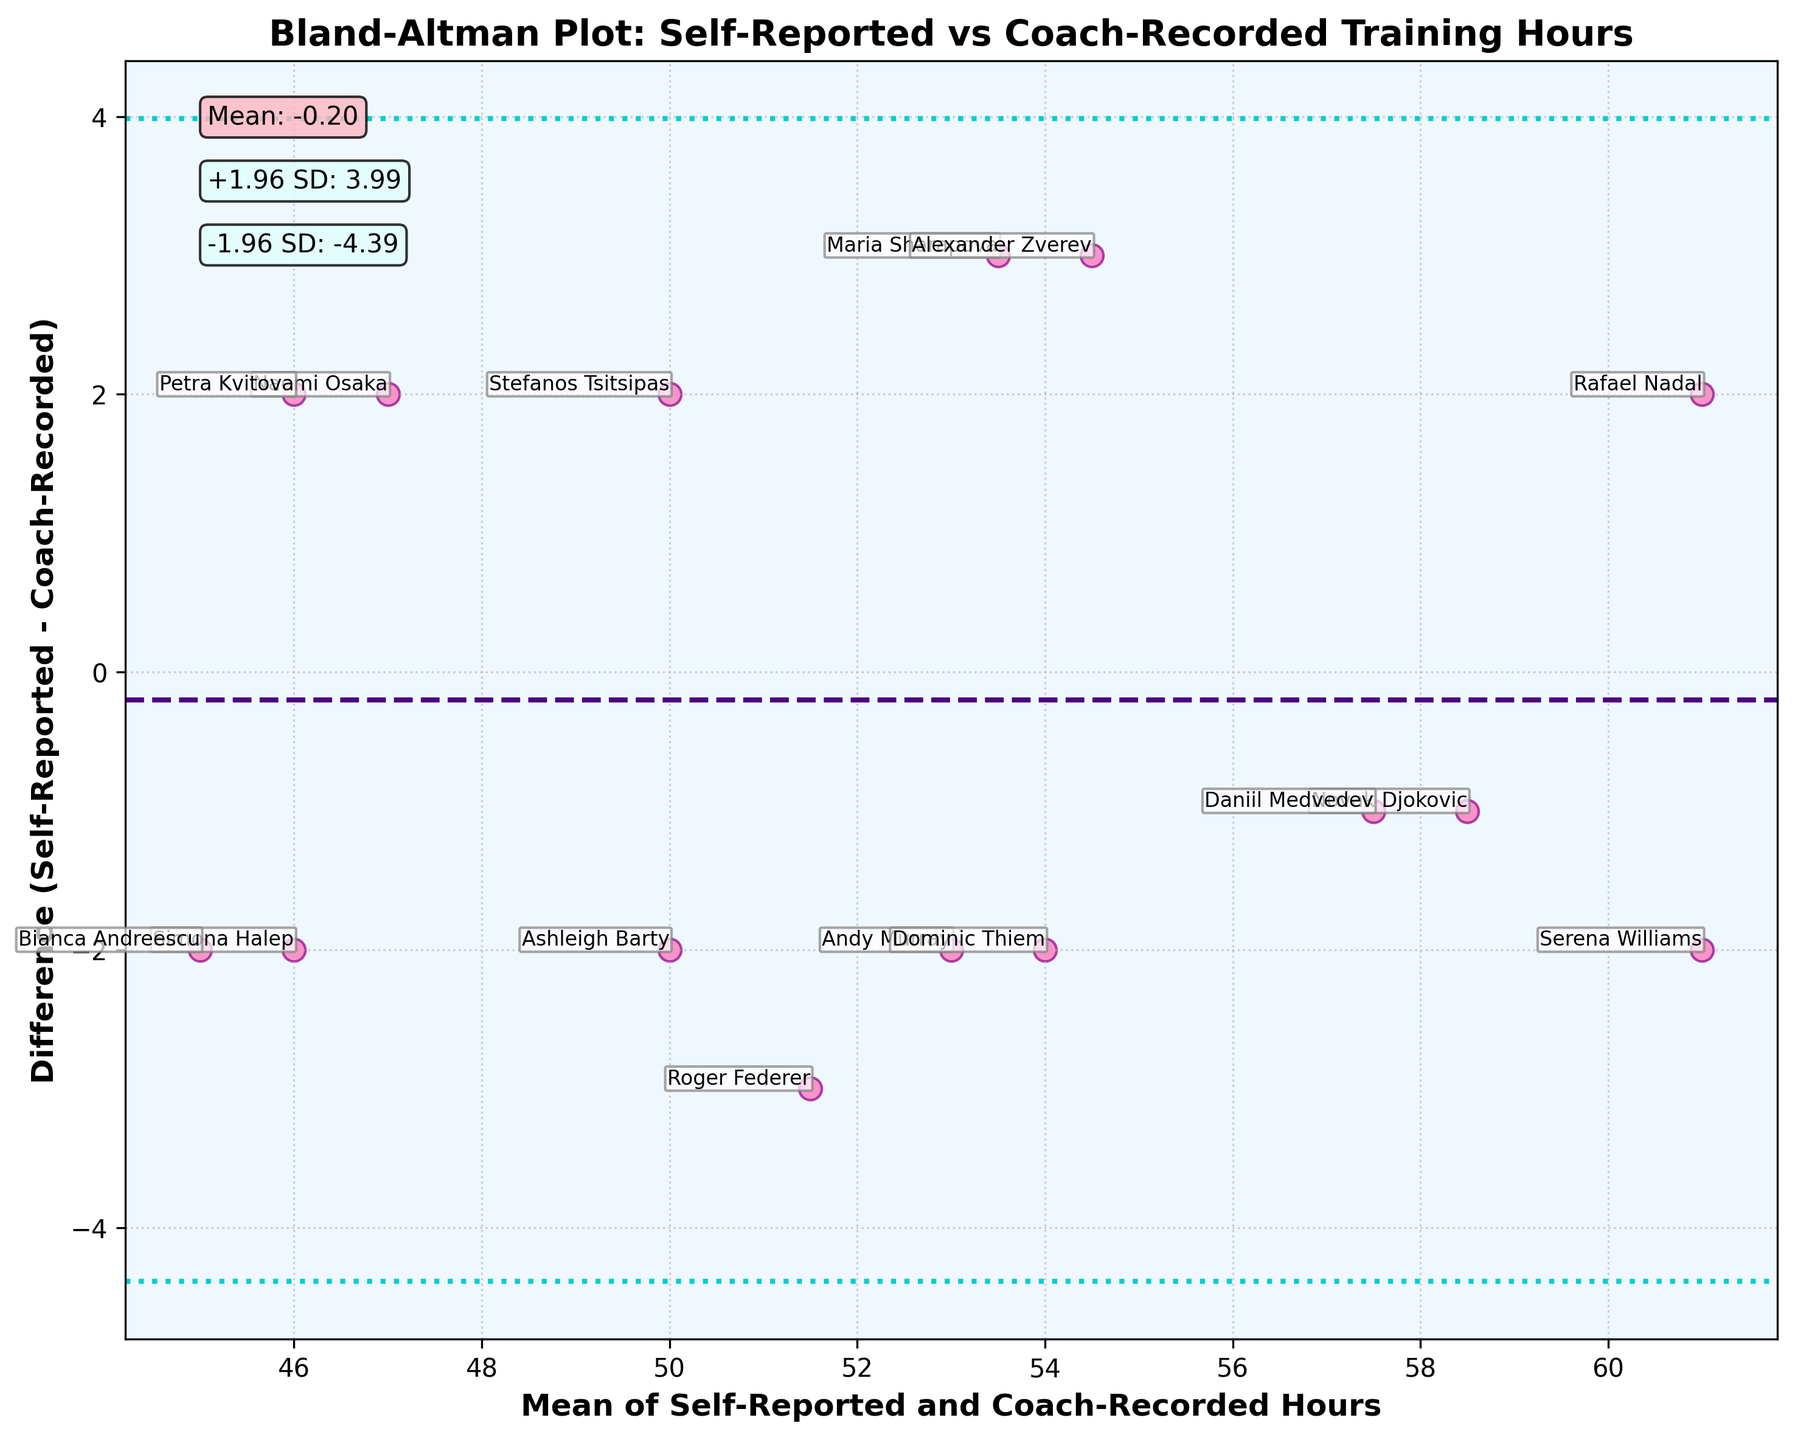What's the title of the plot? The title is written prominently at the top of the plot and states, "Bland-Altman Plot: Self-Reported vs Coach-Recorded Training Hours".
Answer: Bland-Altman Plot: Self-Reported vs Coach-Recorded Training Hours What do the horizontal dashed and dotted lines represent? In Bland-Altman plots, the dashed horizontal line typically represents the mean difference (bias) between the two measurements. The dotted lines often represent the limits of agreement, calculated as the mean difference plus or minus 1.96 times the standard deviation of the differences.
Answer: Mean difference and limits of agreement How many data points are plotted in the figure? Each player in the data lists has a corresponding data point in the plot. There are 15 players given in the data. Therefore, there should be 15 data points plotted.
Answer: 15 What is the vertical position of the mean difference line? The mean difference line's vertical position is indicated on the plot and annotated as "Mean: 0.00". This means the dashed line is positioned at 0.00 on the y-axis.
Answer: 0.00 Who corresponds to the data point with the largest negative difference? The largest negative difference is the data point that is the most below the zero line on the y-axis. By examining the annotations near those points, the largest negative difference corresponds to Roger Federer.
Answer: Roger Federer Which player has a self-reported training hour that exceeds the coach-recorded training hour by 5 hours? The difference value to look for is 5 on the y-axis, indicating self-reported hours are 5 hours more than coach-recorded hours. Upon checking the annotations, Maria Sharapova is the player with this value.
Answer: Maria Sharapova What is the range of the x-axis in the plot? The x-axis represents the mean of self-reported and coach-recorded hours. By checking the data points spread along the axis, we can see the mean ranges from about 45 to 56.
Answer: 45 to 56 Which players' data points lie on the mean difference line? Data points lying on the zero line (mean difference) indicate no difference between self-reported and coach-recorded hours. Examining the annotations along the dashed line, these players are Novak Djokovic and Daniil Medvedev.
Answer: Novak Djokovic and Daniil Medvedev What is the upper limit of agreement shown in the plot? The upper limit of agreement is the mean difference plus 1.96 times the standard deviation. It is annotated in the plot as "+1.96 SD: 3.42".
Answer: 3.42 What does the color scheme in the plot represent? The color scheme in the plot uses pink for data points, purple for the mean difference line, and cyan for the limits of agreement. These colors help differentiate these elements visually.
Answer: Differentiates data points, mean difference line, and limits of agreement 